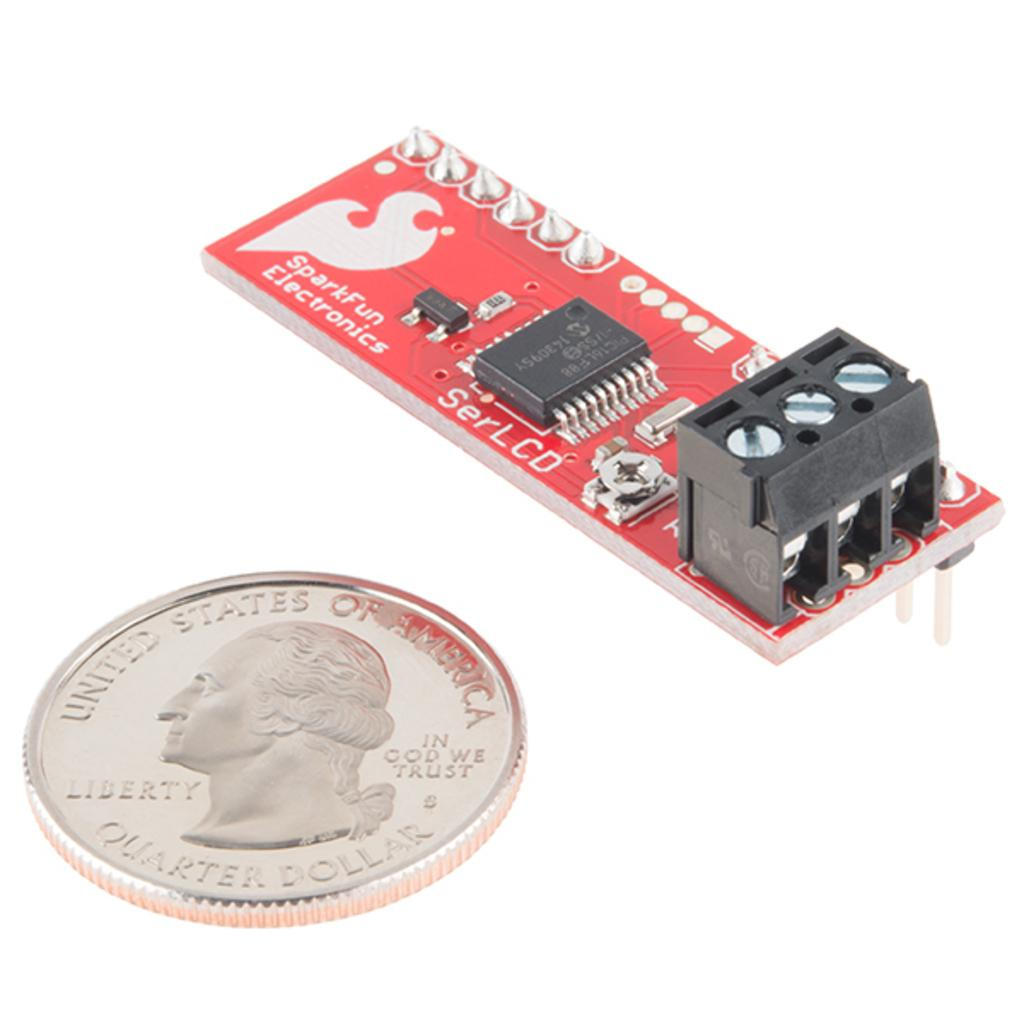<image>
Relay a brief, clear account of the picture shown. A circuit board is displayed by a shiny U.S. quarter dollar to demonstrate its size. 